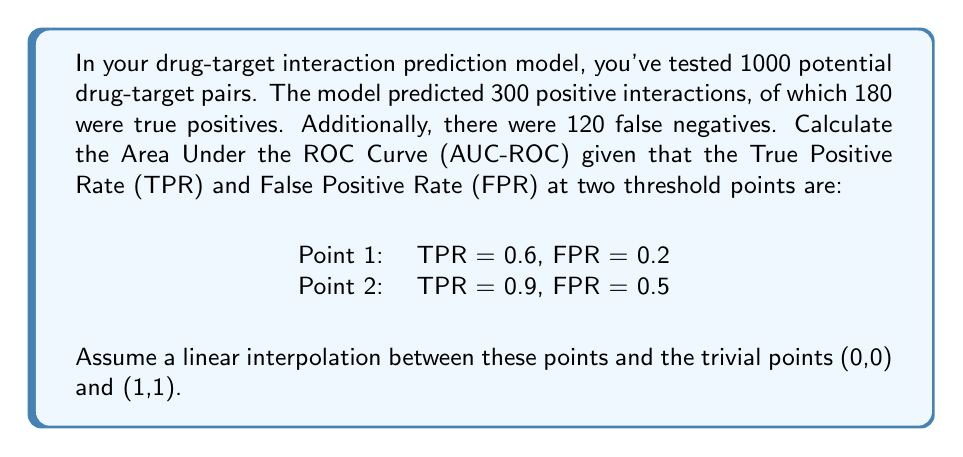Can you solve this math problem? Let's approach this step-by-step:

1) First, let's calculate the total number of actual positive and negative cases:
   True Positives (TP) + False Negatives (FN) = 180 + 120 = 300 actual positives
   Total - Actual Positives = 1000 - 300 = 700 actual negatives

2) Now, we have four points on our ROC curve:
   (0,0), (0.2, 0.6), (0.5, 0.9), (1,1)

3) To calculate the AUC, we'll use the trapezoidal rule. The area will be the sum of three trapezoids.

4) Area of trapezoid 1 (between 0,0 and 0.2,0.6):
   $$A_1 = \frac{1}{2}(0 + 0.6)(0.2 - 0) = 0.06$$

5) Area of trapezoid 2 (between 0.2,0.6 and 0.5,0.9):
   $$A_2 = \frac{1}{2}(0.6 + 0.9)(0.5 - 0.2) = 0.225$$

6) Area of trapezoid 3 (between 0.5,0.9 and 1,1):
   $$A_3 = \frac{1}{2}(0.9 + 1)(1 - 0.5) = 0.475$$

7) Total AUC:
   $$AUC = A_1 + A_2 + A_3 = 0.06 + 0.225 + 0.475 = 0.76$$

Therefore, the Area Under the ROC Curve (AUC-ROC) is 0.76.
Answer: 0.76 